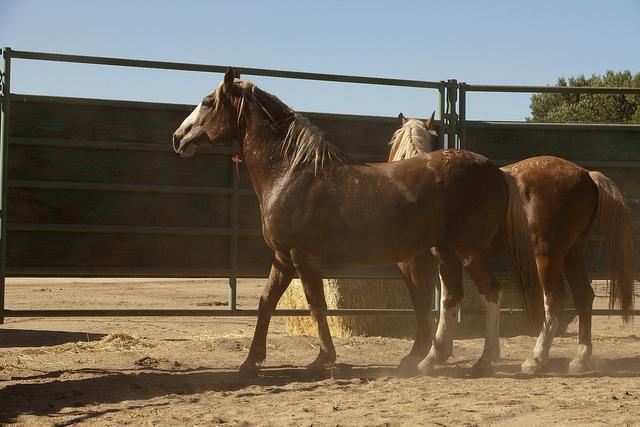How many animals are there?
Give a very brief answer. 2. How many horses are facing the other way?
Give a very brief answer. 1. How many horses are there total?
Give a very brief answer. 2. How many horses can you see?
Give a very brief answer. 2. 